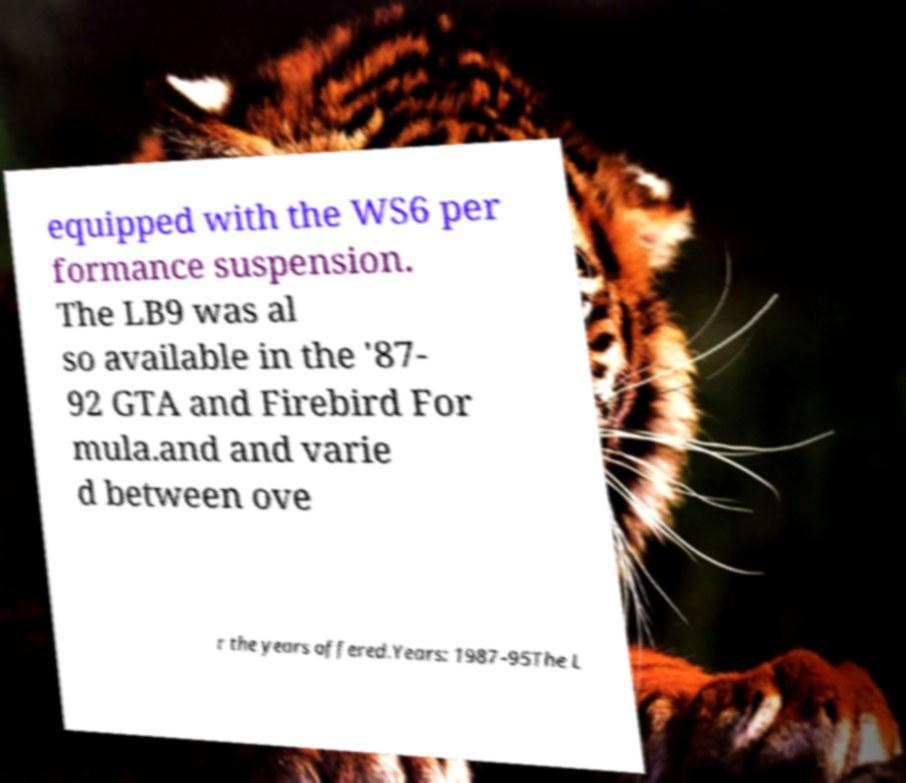Please identify and transcribe the text found in this image. equipped with the WS6 per formance suspension. The LB9 was al so available in the '87- 92 GTA and Firebird For mula.and and varie d between ove r the years offered.Years: 1987–95The L 